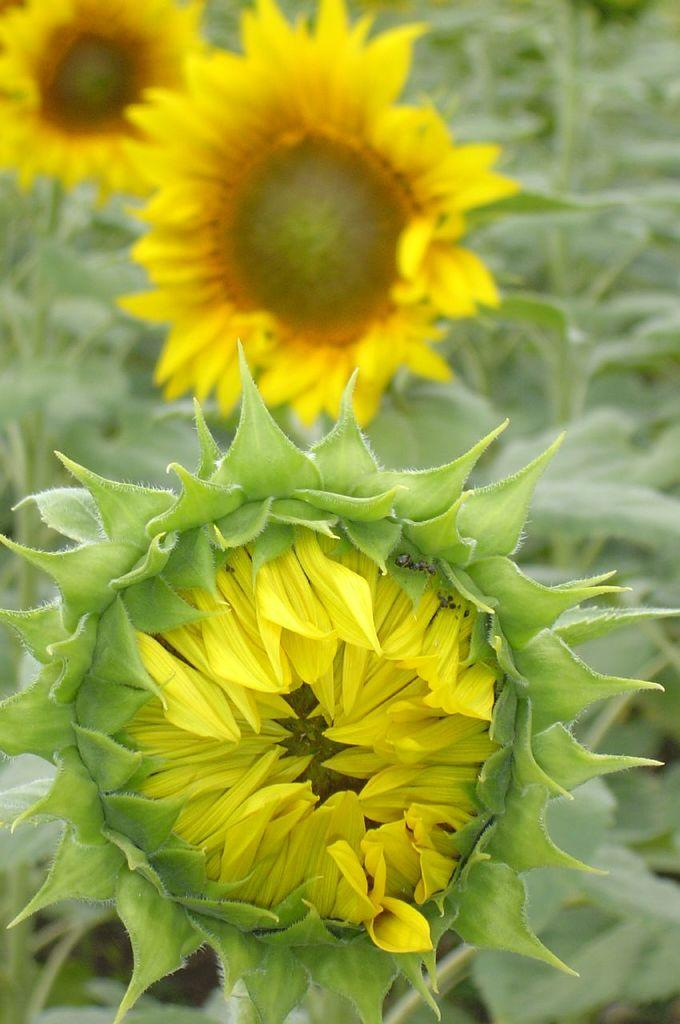What type of living organisms can be seen in the image? There are flowers in the image. What do the flowers belong to? The flowers belong to a plant. What type of fowl can be seen in the image? There is no fowl present in the image; it only features flowers belonging to a plant. 